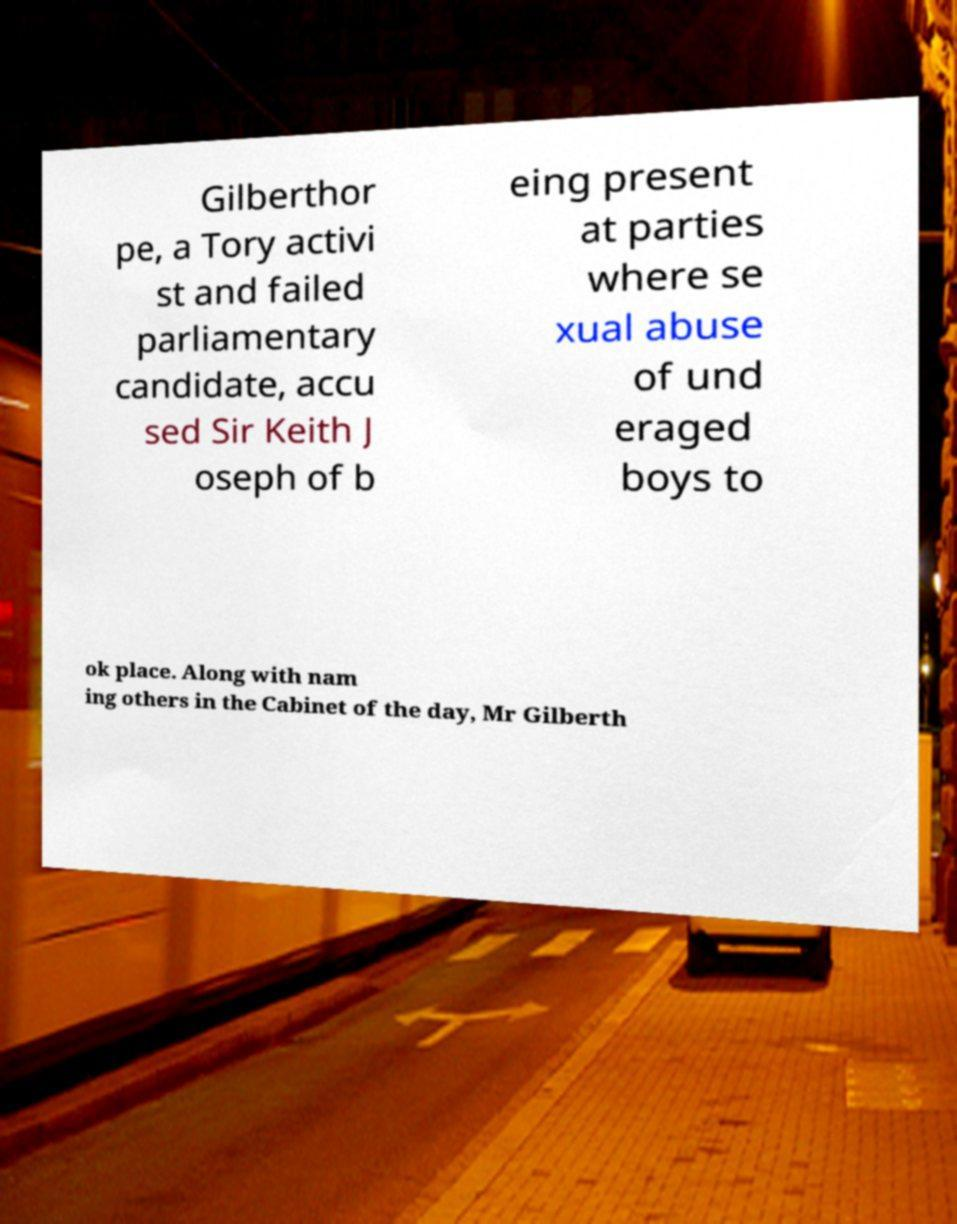Please read and relay the text visible in this image. What does it say? Gilberthor pe, a Tory activi st and failed parliamentary candidate, accu sed Sir Keith J oseph of b eing present at parties where se xual abuse of und eraged boys to ok place. Along with nam ing others in the Cabinet of the day, Mr Gilberth 